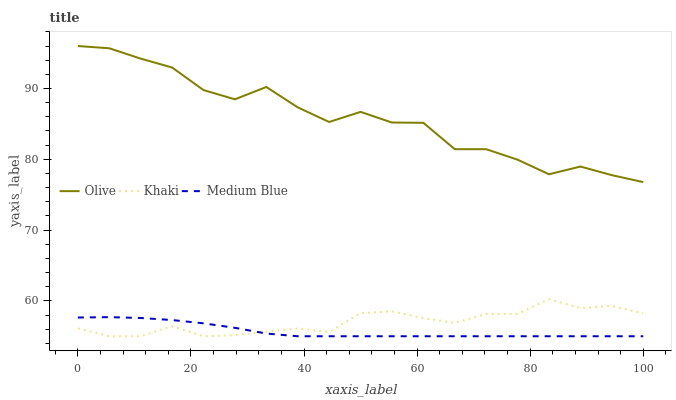Does Medium Blue have the minimum area under the curve?
Answer yes or no. Yes. Does Olive have the maximum area under the curve?
Answer yes or no. Yes. Does Khaki have the minimum area under the curve?
Answer yes or no. No. Does Khaki have the maximum area under the curve?
Answer yes or no. No. Is Medium Blue the smoothest?
Answer yes or no. Yes. Is Olive the roughest?
Answer yes or no. Yes. Is Khaki the smoothest?
Answer yes or no. No. Is Khaki the roughest?
Answer yes or no. No. Does Khaki have the lowest value?
Answer yes or no. Yes. Does Olive have the highest value?
Answer yes or no. Yes. Does Khaki have the highest value?
Answer yes or no. No. Is Medium Blue less than Olive?
Answer yes or no. Yes. Is Olive greater than Khaki?
Answer yes or no. Yes. Does Khaki intersect Medium Blue?
Answer yes or no. Yes. Is Khaki less than Medium Blue?
Answer yes or no. No. Is Khaki greater than Medium Blue?
Answer yes or no. No. Does Medium Blue intersect Olive?
Answer yes or no. No. 